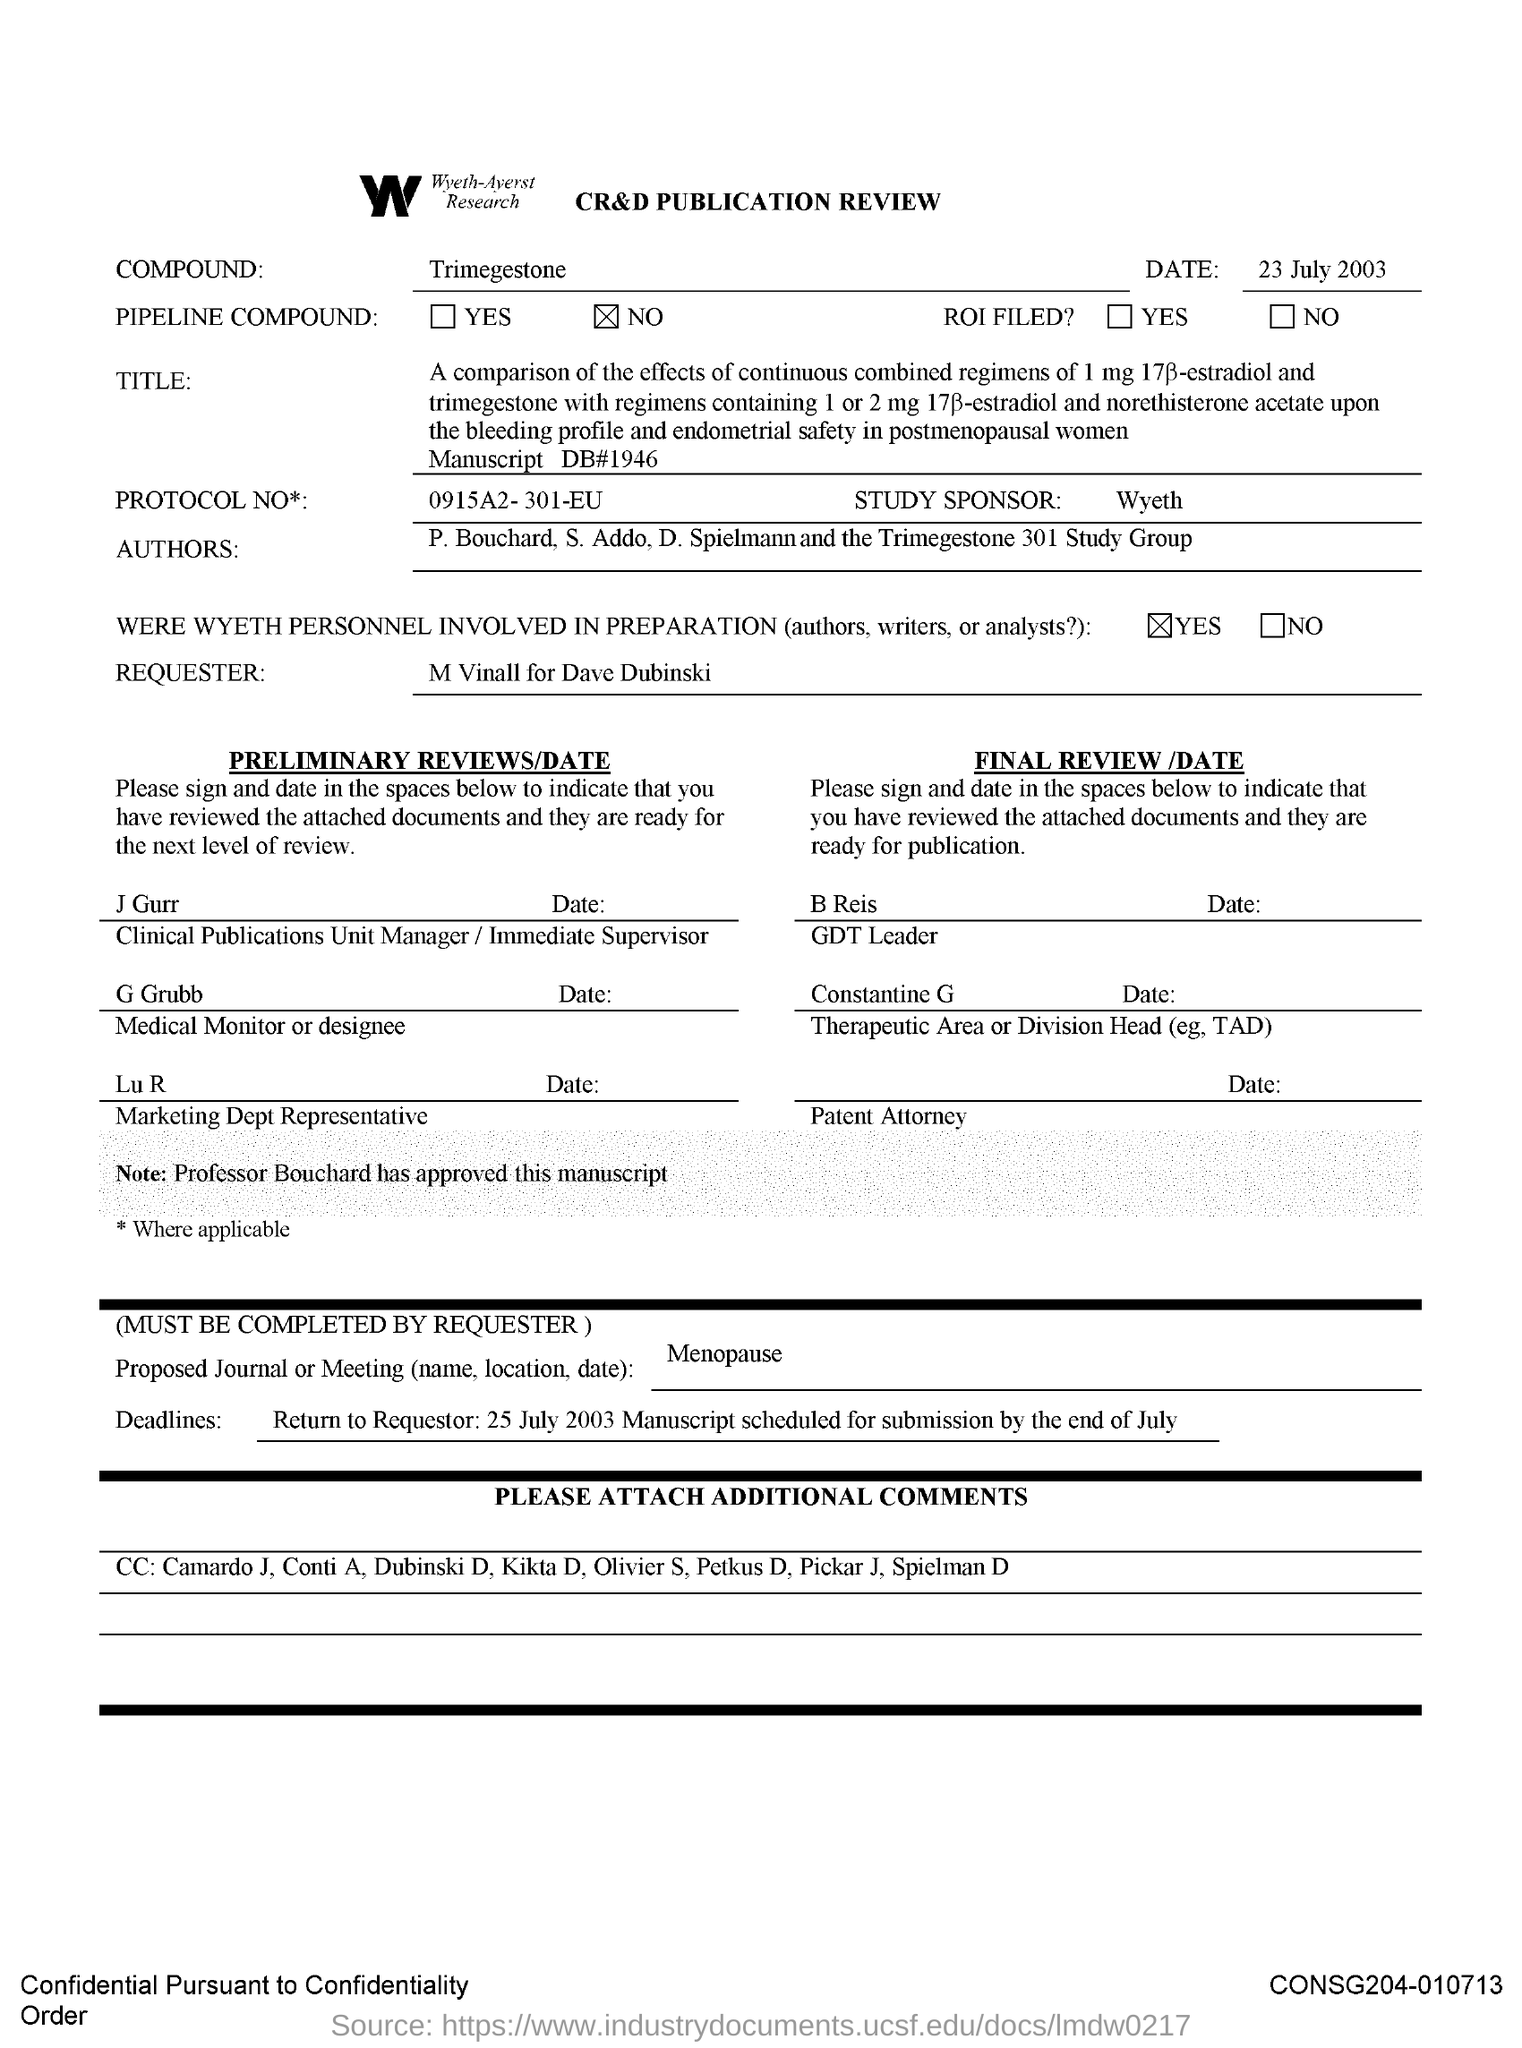Give some essential details in this illustration. Trimegestone is a compound composed of three elements: silicon, aluminum, and oxygen. The date is July 23, 2003. Wyeth is the sponsor of the study. 